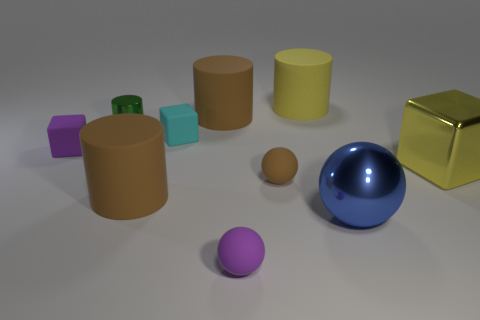Subtract all shiny cubes. How many cubes are left? 2 Subtract all brown balls. How many balls are left? 2 Subtract all blocks. How many objects are left? 7 Subtract all yellow cylinders. How many purple spheres are left? 1 Subtract all big metallic spheres. Subtract all tiny brown rubber spheres. How many objects are left? 8 Add 2 small purple spheres. How many small purple spheres are left? 3 Add 6 small blue cylinders. How many small blue cylinders exist? 6 Subtract 2 brown cylinders. How many objects are left? 8 Subtract 2 cubes. How many cubes are left? 1 Subtract all blue balls. Subtract all cyan cylinders. How many balls are left? 2 